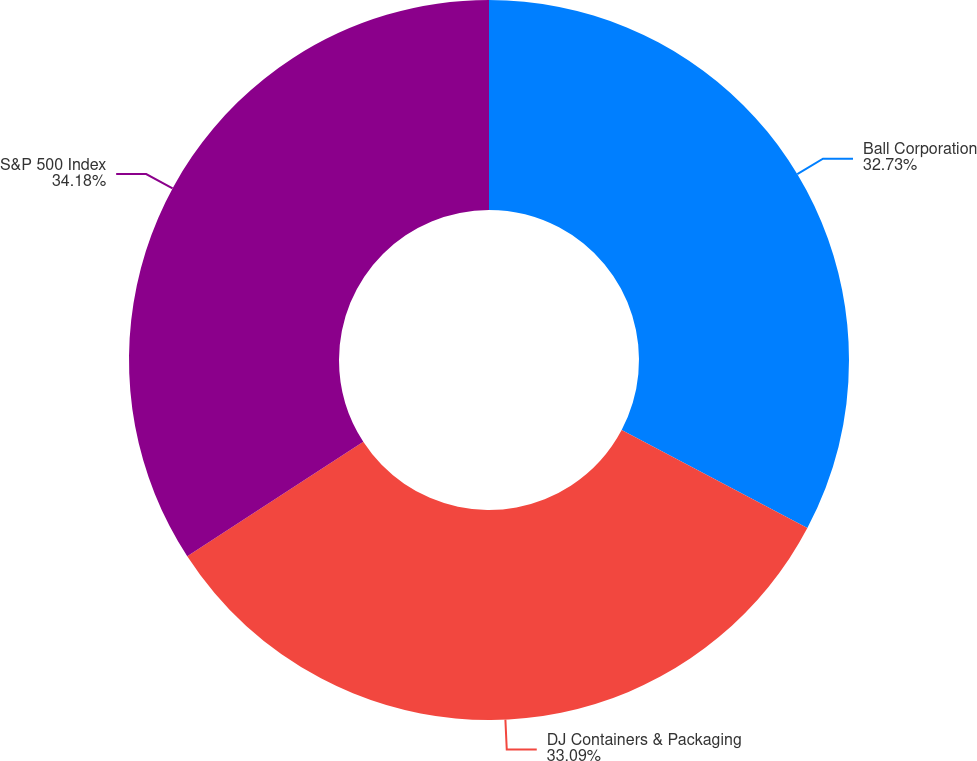Convert chart. <chart><loc_0><loc_0><loc_500><loc_500><pie_chart><fcel>Ball Corporation<fcel>DJ Containers & Packaging<fcel>S&P 500 Index<nl><fcel>32.73%<fcel>33.09%<fcel>34.18%<nl></chart> 